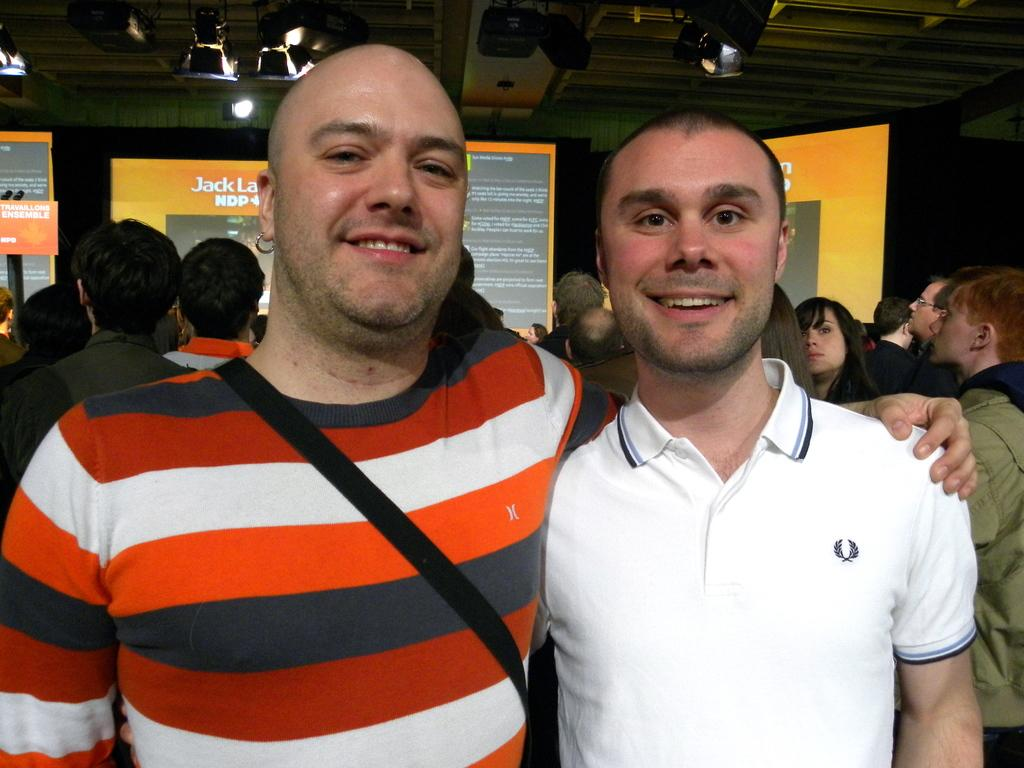<image>
Offer a succinct explanation of the picture presented. Man in striped shirt has arm around another man in front of orange screen with the word "Jack" displayed. 